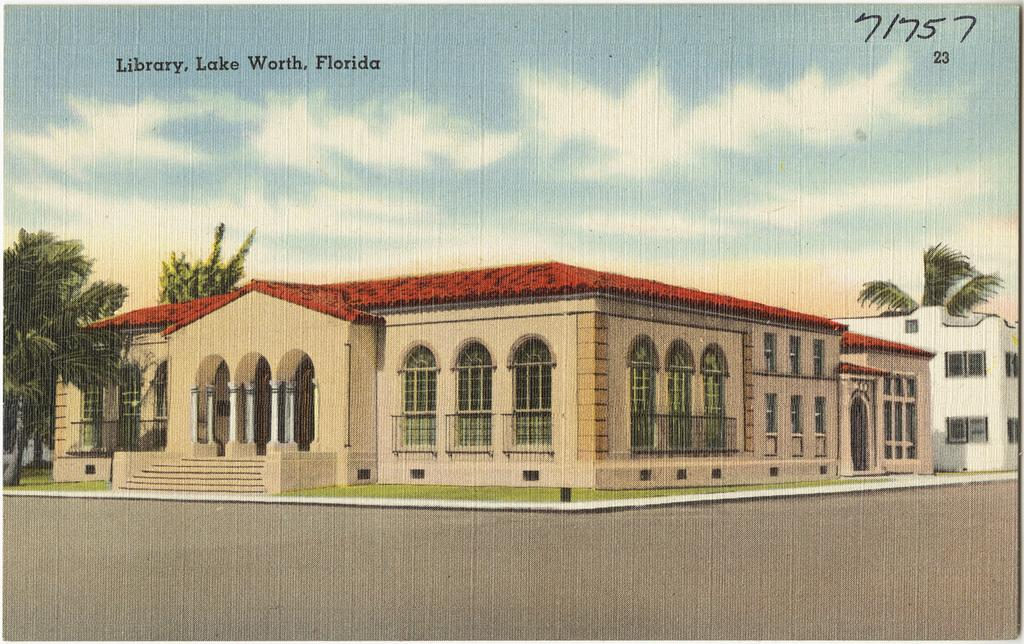What type of visual is the image? The image is a poster. What structures are depicted on the poster? There are buildings depicted on the poster. What type of natural elements are shown on the poster? There are trees depicted on the poster. What part of the environment is visible on the poster? The sky is visible on the poster. What type of information is present on the poster? There are numbers and words present on the poster. Can you tell me how many babies are depicted in the argument on the poster? There are no babies or arguments depicted on the poster; it features buildings, trees, the sky, numbers, and words. What type of peace is represented by the poster? The poster does not represent any specific type of peace; it is a visual display of buildings, trees, the sky, numbers, and words. 